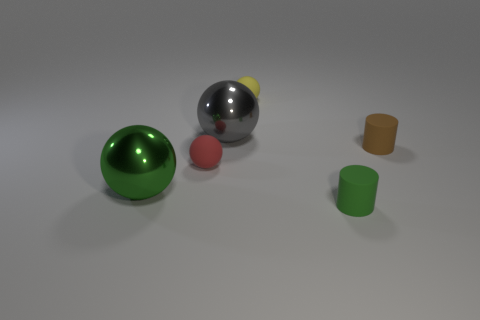Subtract all blue spheres. Subtract all red blocks. How many spheres are left? 4 Add 3 tiny green cylinders. How many objects exist? 9 Subtract all balls. How many objects are left? 2 Add 1 tiny yellow shiny spheres. How many tiny yellow shiny spheres exist? 1 Subtract 1 green cylinders. How many objects are left? 5 Subtract all red matte objects. Subtract all large gray objects. How many objects are left? 4 Add 6 large green metal spheres. How many large green metal spheres are left? 7 